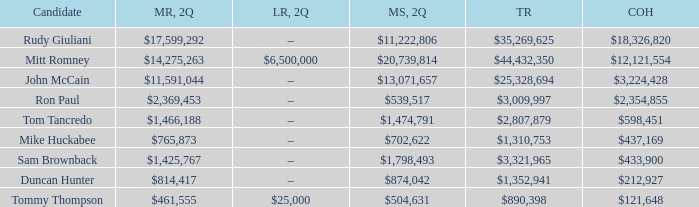Name the money raised when 2Q has money spent and 2Q is $874,042 $814,417. 